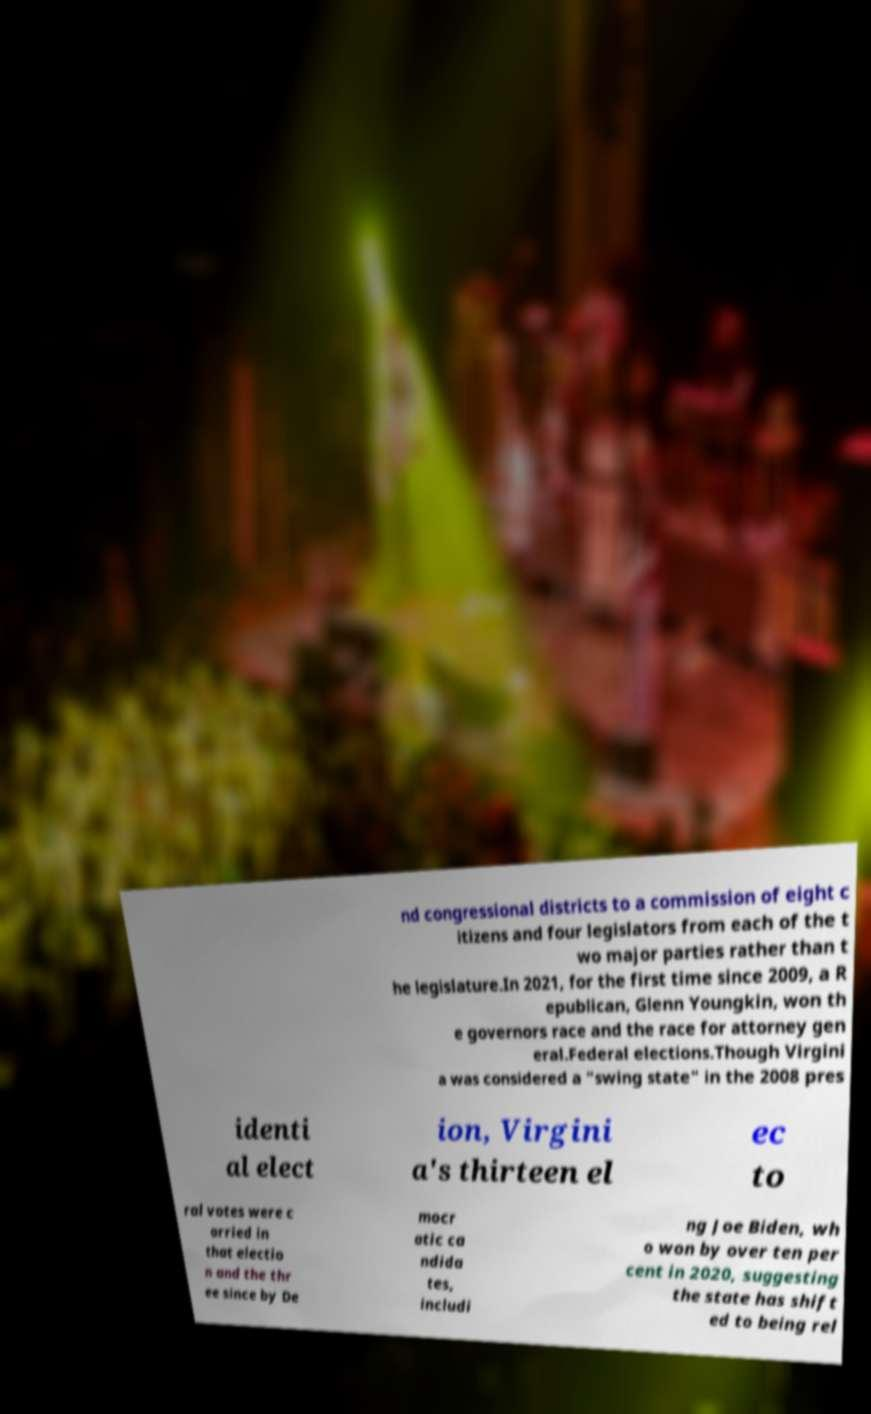Can you accurately transcribe the text from the provided image for me? nd congressional districts to a commission of eight c itizens and four legislators from each of the t wo major parties rather than t he legislature.In 2021, for the first time since 2009, a R epublican, Glenn Youngkin, won th e governors race and the race for attorney gen eral.Federal elections.Though Virgini a was considered a "swing state" in the 2008 pres identi al elect ion, Virgini a's thirteen el ec to ral votes were c arried in that electio n and the thr ee since by De mocr atic ca ndida tes, includi ng Joe Biden, wh o won by over ten per cent in 2020, suggesting the state has shift ed to being rel 